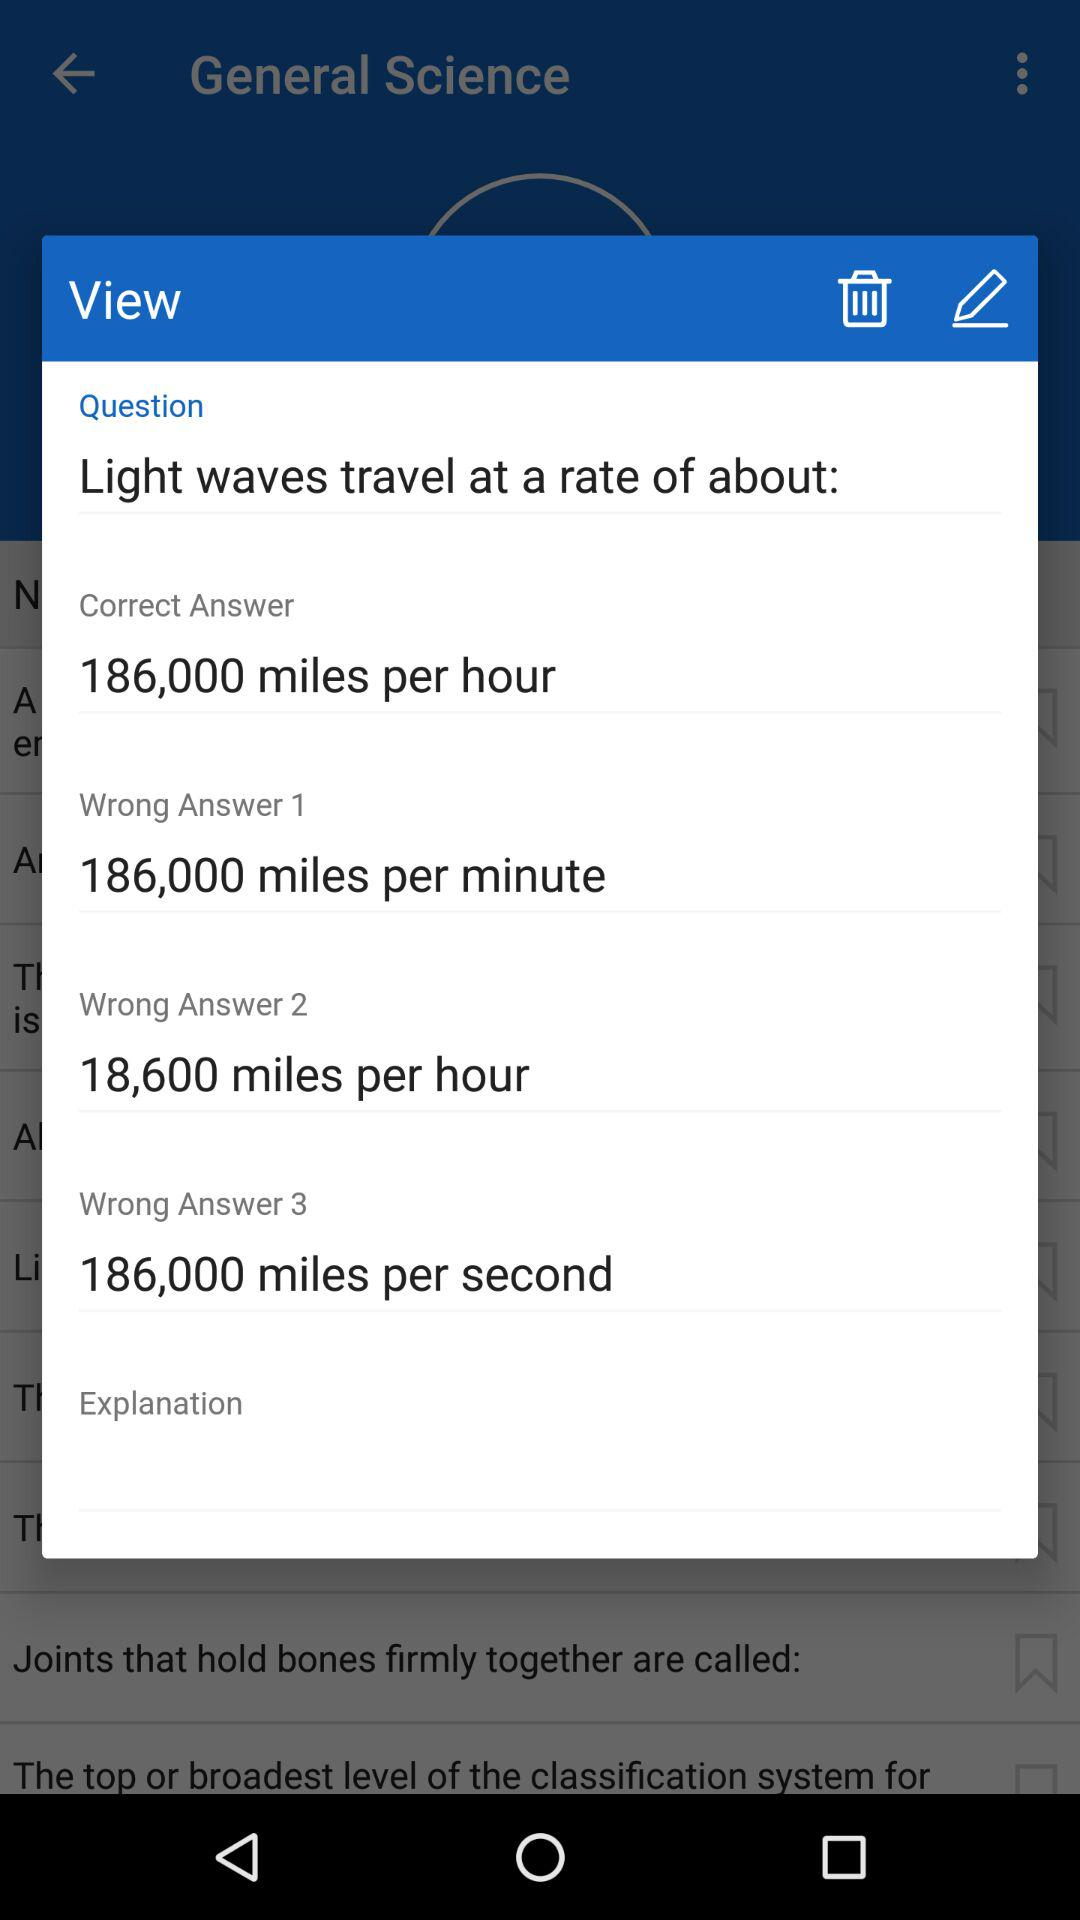What is the "Wrong Answer 3"? The "Wrong Answer 3" is 186,000 miles per second. 